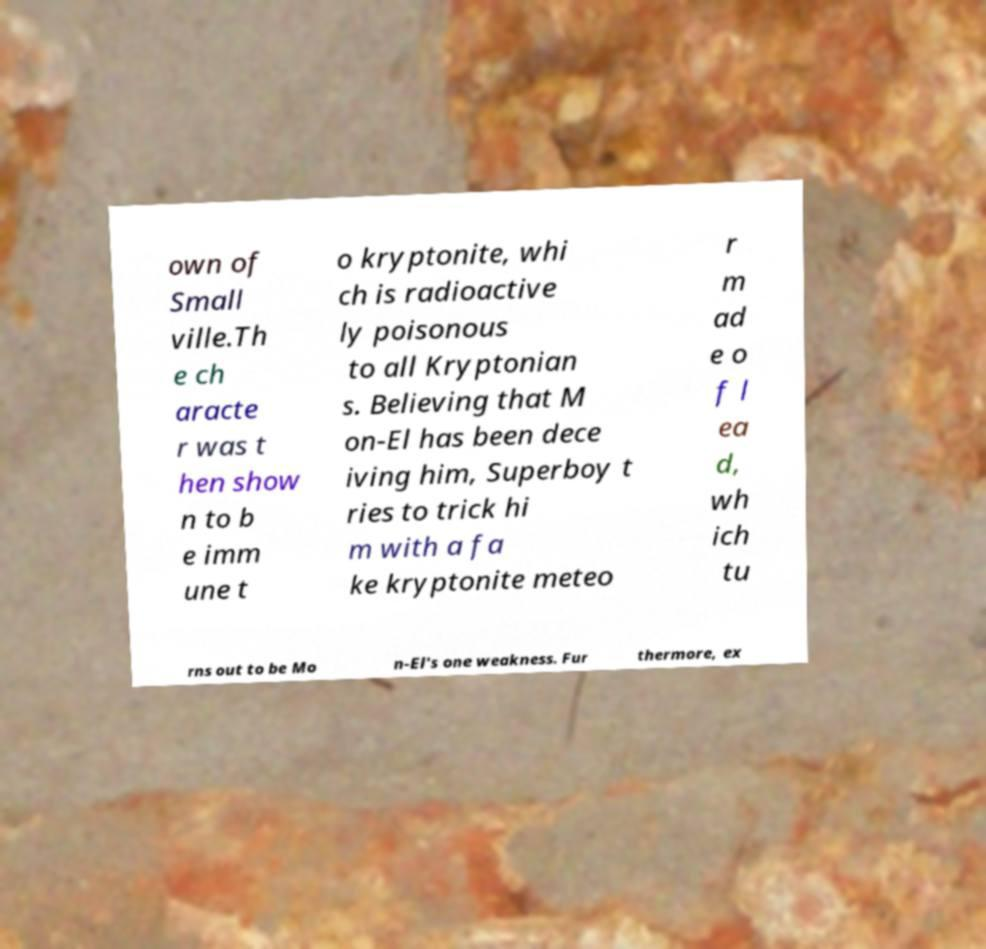Could you assist in decoding the text presented in this image and type it out clearly? own of Small ville.Th e ch aracte r was t hen show n to b e imm une t o kryptonite, whi ch is radioactive ly poisonous to all Kryptonian s. Believing that M on-El has been dece iving him, Superboy t ries to trick hi m with a fa ke kryptonite meteo r m ad e o f l ea d, wh ich tu rns out to be Mo n-El's one weakness. Fur thermore, ex 